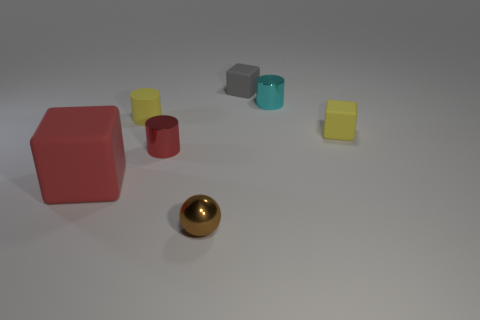What number of other things are there of the same color as the big cube?
Keep it short and to the point. 1. There is a cyan thing that is the same size as the gray thing; what shape is it?
Your response must be concise. Cylinder. How many tiny things are blocks or yellow things?
Provide a short and direct response. 3. There is a rubber cube right of the small rubber cube to the left of the yellow cube; are there any shiny balls that are right of it?
Offer a terse response. No. Is there a cyan shiny thing of the same size as the red cylinder?
Offer a terse response. Yes. There is a brown thing that is the same size as the gray matte object; what material is it?
Keep it short and to the point. Metal. There is a cyan object; does it have the same size as the red object behind the red cube?
Provide a succinct answer. Yes. How many matte objects are yellow cubes or cyan cylinders?
Your answer should be very brief. 1. What number of other small rubber things have the same shape as the red matte thing?
Provide a short and direct response. 2. What is the material of the tiny object that is the same color as the rubber cylinder?
Provide a short and direct response. Rubber. 